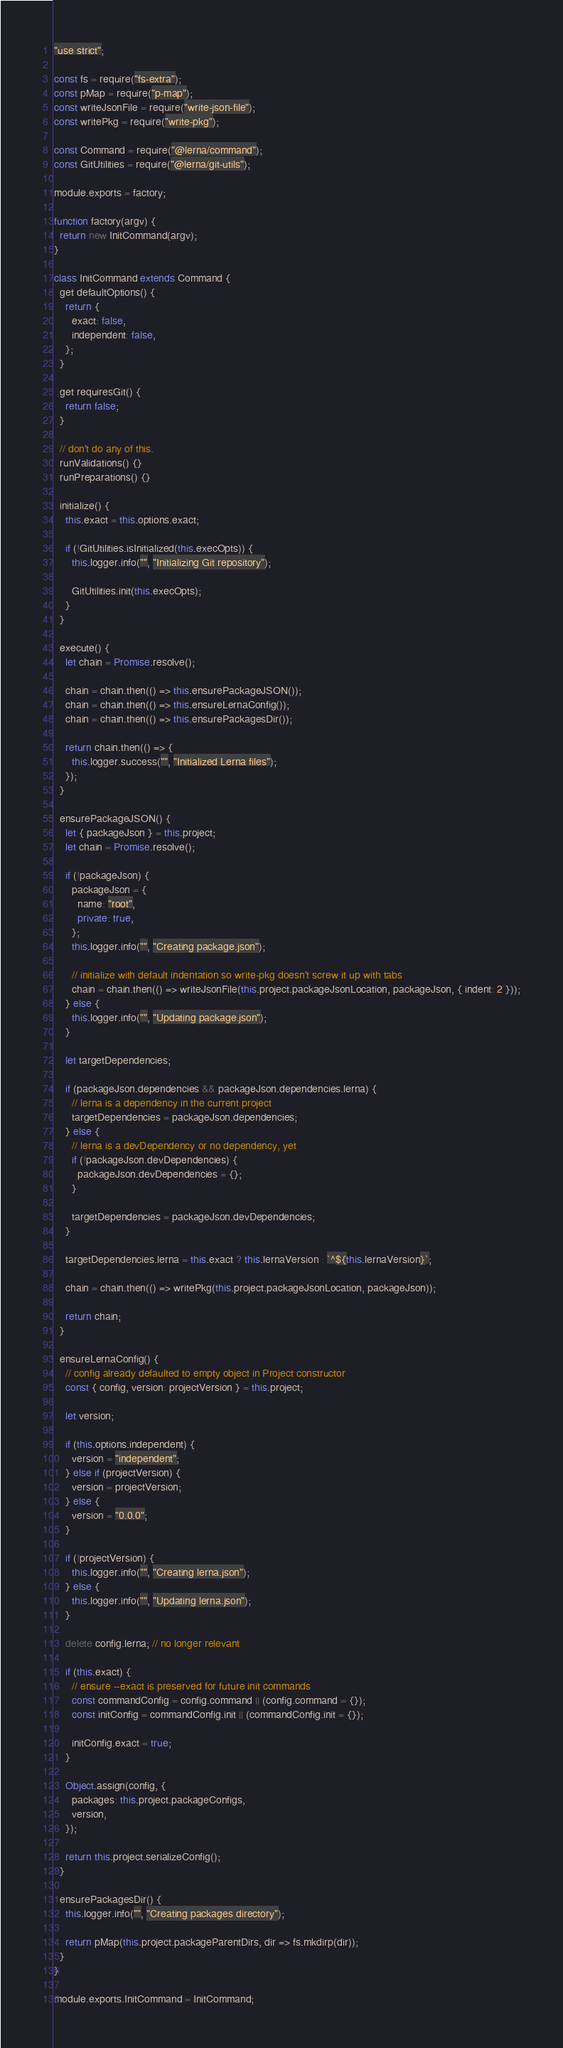<code> <loc_0><loc_0><loc_500><loc_500><_JavaScript_>"use strict";

const fs = require("fs-extra");
const pMap = require("p-map");
const writeJsonFile = require("write-json-file");
const writePkg = require("write-pkg");

const Command = require("@lerna/command");
const GitUtilities = require("@lerna/git-utils");

module.exports = factory;

function factory(argv) {
  return new InitCommand(argv);
}

class InitCommand extends Command {
  get defaultOptions() {
    return {
      exact: false,
      independent: false,
    };
  }

  get requiresGit() {
    return false;
  }

  // don't do any of this.
  runValidations() {}
  runPreparations() {}

  initialize() {
    this.exact = this.options.exact;

    if (!GitUtilities.isInitialized(this.execOpts)) {
      this.logger.info("", "Initializing Git repository");

      GitUtilities.init(this.execOpts);
    }
  }

  execute() {
    let chain = Promise.resolve();

    chain = chain.then(() => this.ensurePackageJSON());
    chain = chain.then(() => this.ensureLernaConfig());
    chain = chain.then(() => this.ensurePackagesDir());

    return chain.then(() => {
      this.logger.success("", "Initialized Lerna files");
    });
  }

  ensurePackageJSON() {
    let { packageJson } = this.project;
    let chain = Promise.resolve();

    if (!packageJson) {
      packageJson = {
        name: "root",
        private: true,
      };
      this.logger.info("", "Creating package.json");

      // initialize with default indentation so write-pkg doesn't screw it up with tabs
      chain = chain.then(() => writeJsonFile(this.project.packageJsonLocation, packageJson, { indent: 2 }));
    } else {
      this.logger.info("", "Updating package.json");
    }

    let targetDependencies;

    if (packageJson.dependencies && packageJson.dependencies.lerna) {
      // lerna is a dependency in the current project
      targetDependencies = packageJson.dependencies;
    } else {
      // lerna is a devDependency or no dependency, yet
      if (!packageJson.devDependencies) {
        packageJson.devDependencies = {};
      }

      targetDependencies = packageJson.devDependencies;
    }

    targetDependencies.lerna = this.exact ? this.lernaVersion : `^${this.lernaVersion}`;

    chain = chain.then(() => writePkg(this.project.packageJsonLocation, packageJson));

    return chain;
  }

  ensureLernaConfig() {
    // config already defaulted to empty object in Project constructor
    const { config, version: projectVersion } = this.project;

    let version;

    if (this.options.independent) {
      version = "independent";
    } else if (projectVersion) {
      version = projectVersion;
    } else {
      version = "0.0.0";
    }

    if (!projectVersion) {
      this.logger.info("", "Creating lerna.json");
    } else {
      this.logger.info("", "Updating lerna.json");
    }

    delete config.lerna; // no longer relevant

    if (this.exact) {
      // ensure --exact is preserved for future init commands
      const commandConfig = config.command || (config.command = {});
      const initConfig = commandConfig.init || (commandConfig.init = {});

      initConfig.exact = true;
    }

    Object.assign(config, {
      packages: this.project.packageConfigs,
      version,
    });

    return this.project.serializeConfig();
  }

  ensurePackagesDir() {
    this.logger.info("", "Creating packages directory");

    return pMap(this.project.packageParentDirs, dir => fs.mkdirp(dir));
  }
}

module.exports.InitCommand = InitCommand;
</code> 